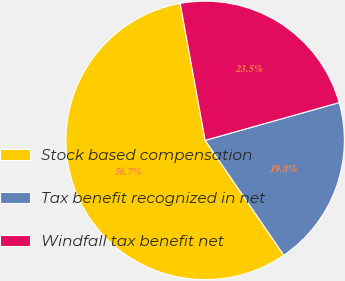<chart> <loc_0><loc_0><loc_500><loc_500><pie_chart><fcel>Stock based compensation<fcel>Tax benefit recognized in net<fcel>Windfall tax benefit net<nl><fcel>56.69%<fcel>19.81%<fcel>23.5%<nl></chart> 